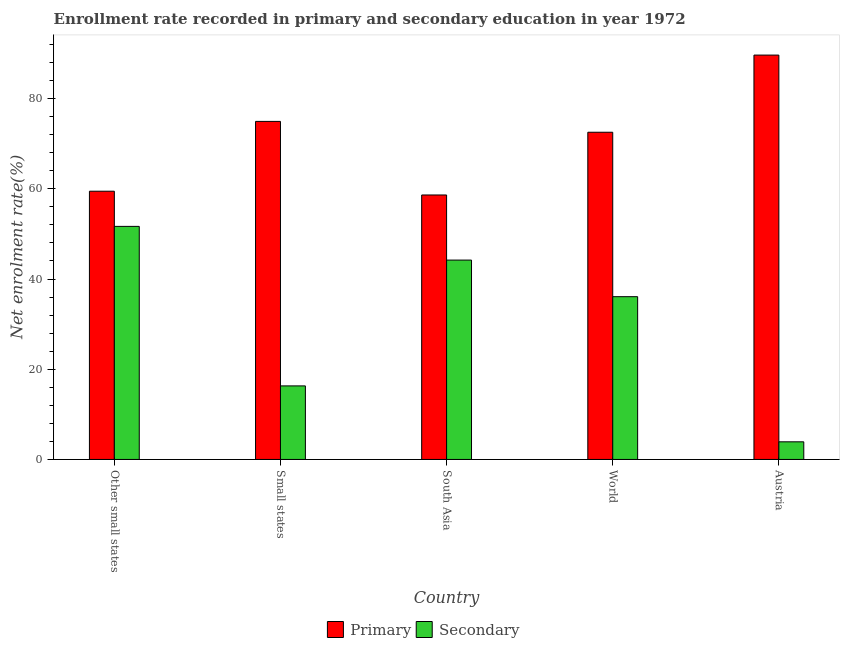How many different coloured bars are there?
Make the answer very short. 2. Are the number of bars on each tick of the X-axis equal?
Make the answer very short. Yes. How many bars are there on the 1st tick from the right?
Offer a terse response. 2. What is the label of the 1st group of bars from the left?
Keep it short and to the point. Other small states. What is the enrollment rate in secondary education in World?
Provide a short and direct response. 36.08. Across all countries, what is the maximum enrollment rate in primary education?
Keep it short and to the point. 89.64. Across all countries, what is the minimum enrollment rate in secondary education?
Give a very brief answer. 3.91. In which country was the enrollment rate in secondary education maximum?
Keep it short and to the point. Other small states. What is the total enrollment rate in secondary education in the graph?
Keep it short and to the point. 152.16. What is the difference between the enrollment rate in secondary education in Other small states and that in World?
Provide a succinct answer. 15.58. What is the difference between the enrollment rate in primary education in Small states and the enrollment rate in secondary education in South Asia?
Offer a terse response. 30.75. What is the average enrollment rate in primary education per country?
Keep it short and to the point. 71.04. What is the difference between the enrollment rate in secondary education and enrollment rate in primary education in Small states?
Your answer should be very brief. -58.63. In how many countries, is the enrollment rate in secondary education greater than 52 %?
Your answer should be compact. 0. What is the ratio of the enrollment rate in secondary education in Austria to that in South Asia?
Offer a very short reply. 0.09. What is the difference between the highest and the second highest enrollment rate in secondary education?
Offer a very short reply. 7.47. What is the difference between the highest and the lowest enrollment rate in primary education?
Give a very brief answer. 31.01. In how many countries, is the enrollment rate in primary education greater than the average enrollment rate in primary education taken over all countries?
Ensure brevity in your answer.  3. What does the 2nd bar from the left in South Asia represents?
Offer a terse response. Secondary. What does the 1st bar from the right in Other small states represents?
Provide a short and direct response. Secondary. How many bars are there?
Provide a short and direct response. 10. How many countries are there in the graph?
Offer a terse response. 5. What is the difference between two consecutive major ticks on the Y-axis?
Offer a very short reply. 20. Are the values on the major ticks of Y-axis written in scientific E-notation?
Your answer should be compact. No. Does the graph contain any zero values?
Ensure brevity in your answer.  No. Does the graph contain grids?
Your response must be concise. No. Where does the legend appear in the graph?
Your response must be concise. Bottom center. How are the legend labels stacked?
Your response must be concise. Horizontal. What is the title of the graph?
Offer a terse response. Enrollment rate recorded in primary and secondary education in year 1972. What is the label or title of the X-axis?
Your response must be concise. Country. What is the label or title of the Y-axis?
Offer a terse response. Net enrolment rate(%). What is the Net enrolment rate(%) in Primary in Other small states?
Offer a terse response. 59.47. What is the Net enrolment rate(%) of Secondary in Other small states?
Ensure brevity in your answer.  51.67. What is the Net enrolment rate(%) of Primary in Small states?
Provide a short and direct response. 74.94. What is the Net enrolment rate(%) of Secondary in Small states?
Your response must be concise. 16.31. What is the Net enrolment rate(%) of Primary in South Asia?
Make the answer very short. 58.63. What is the Net enrolment rate(%) of Secondary in South Asia?
Ensure brevity in your answer.  44.2. What is the Net enrolment rate(%) of Primary in World?
Make the answer very short. 72.54. What is the Net enrolment rate(%) of Secondary in World?
Offer a terse response. 36.08. What is the Net enrolment rate(%) of Primary in Austria?
Ensure brevity in your answer.  89.64. What is the Net enrolment rate(%) in Secondary in Austria?
Your answer should be compact. 3.91. Across all countries, what is the maximum Net enrolment rate(%) in Primary?
Offer a terse response. 89.64. Across all countries, what is the maximum Net enrolment rate(%) of Secondary?
Provide a succinct answer. 51.67. Across all countries, what is the minimum Net enrolment rate(%) in Primary?
Offer a terse response. 58.63. Across all countries, what is the minimum Net enrolment rate(%) of Secondary?
Keep it short and to the point. 3.91. What is the total Net enrolment rate(%) of Primary in the graph?
Make the answer very short. 355.21. What is the total Net enrolment rate(%) of Secondary in the graph?
Your response must be concise. 152.16. What is the difference between the Net enrolment rate(%) in Primary in Other small states and that in Small states?
Your response must be concise. -15.47. What is the difference between the Net enrolment rate(%) in Secondary in Other small states and that in Small states?
Your response must be concise. 35.36. What is the difference between the Net enrolment rate(%) in Primary in Other small states and that in South Asia?
Ensure brevity in your answer.  0.83. What is the difference between the Net enrolment rate(%) in Secondary in Other small states and that in South Asia?
Make the answer very short. 7.47. What is the difference between the Net enrolment rate(%) in Primary in Other small states and that in World?
Offer a terse response. -13.07. What is the difference between the Net enrolment rate(%) of Secondary in Other small states and that in World?
Offer a very short reply. 15.58. What is the difference between the Net enrolment rate(%) in Primary in Other small states and that in Austria?
Provide a short and direct response. -30.17. What is the difference between the Net enrolment rate(%) in Secondary in Other small states and that in Austria?
Make the answer very short. 47.76. What is the difference between the Net enrolment rate(%) of Primary in Small states and that in South Asia?
Make the answer very short. 16.31. What is the difference between the Net enrolment rate(%) of Secondary in Small states and that in South Asia?
Your answer should be very brief. -27.89. What is the difference between the Net enrolment rate(%) of Primary in Small states and that in World?
Provide a succinct answer. 2.4. What is the difference between the Net enrolment rate(%) in Secondary in Small states and that in World?
Give a very brief answer. -19.78. What is the difference between the Net enrolment rate(%) of Primary in Small states and that in Austria?
Keep it short and to the point. -14.7. What is the difference between the Net enrolment rate(%) in Secondary in Small states and that in Austria?
Offer a very short reply. 12.4. What is the difference between the Net enrolment rate(%) of Primary in South Asia and that in World?
Your answer should be very brief. -13.91. What is the difference between the Net enrolment rate(%) in Secondary in South Asia and that in World?
Provide a short and direct response. 8.11. What is the difference between the Net enrolment rate(%) of Primary in South Asia and that in Austria?
Keep it short and to the point. -31.01. What is the difference between the Net enrolment rate(%) of Secondary in South Asia and that in Austria?
Your answer should be very brief. 40.29. What is the difference between the Net enrolment rate(%) of Primary in World and that in Austria?
Give a very brief answer. -17.1. What is the difference between the Net enrolment rate(%) in Secondary in World and that in Austria?
Offer a terse response. 32.18. What is the difference between the Net enrolment rate(%) in Primary in Other small states and the Net enrolment rate(%) in Secondary in Small states?
Give a very brief answer. 43.16. What is the difference between the Net enrolment rate(%) of Primary in Other small states and the Net enrolment rate(%) of Secondary in South Asia?
Give a very brief answer. 15.27. What is the difference between the Net enrolment rate(%) in Primary in Other small states and the Net enrolment rate(%) in Secondary in World?
Make the answer very short. 23.38. What is the difference between the Net enrolment rate(%) of Primary in Other small states and the Net enrolment rate(%) of Secondary in Austria?
Make the answer very short. 55.56. What is the difference between the Net enrolment rate(%) of Primary in Small states and the Net enrolment rate(%) of Secondary in South Asia?
Keep it short and to the point. 30.75. What is the difference between the Net enrolment rate(%) in Primary in Small states and the Net enrolment rate(%) in Secondary in World?
Make the answer very short. 38.86. What is the difference between the Net enrolment rate(%) of Primary in Small states and the Net enrolment rate(%) of Secondary in Austria?
Provide a succinct answer. 71.03. What is the difference between the Net enrolment rate(%) in Primary in South Asia and the Net enrolment rate(%) in Secondary in World?
Keep it short and to the point. 22.55. What is the difference between the Net enrolment rate(%) in Primary in South Asia and the Net enrolment rate(%) in Secondary in Austria?
Give a very brief answer. 54.72. What is the difference between the Net enrolment rate(%) of Primary in World and the Net enrolment rate(%) of Secondary in Austria?
Keep it short and to the point. 68.63. What is the average Net enrolment rate(%) in Primary per country?
Give a very brief answer. 71.04. What is the average Net enrolment rate(%) of Secondary per country?
Provide a short and direct response. 30.43. What is the difference between the Net enrolment rate(%) in Primary and Net enrolment rate(%) in Secondary in Other small states?
Your answer should be compact. 7.8. What is the difference between the Net enrolment rate(%) of Primary and Net enrolment rate(%) of Secondary in Small states?
Provide a short and direct response. 58.63. What is the difference between the Net enrolment rate(%) in Primary and Net enrolment rate(%) in Secondary in South Asia?
Ensure brevity in your answer.  14.44. What is the difference between the Net enrolment rate(%) in Primary and Net enrolment rate(%) in Secondary in World?
Give a very brief answer. 36.45. What is the difference between the Net enrolment rate(%) in Primary and Net enrolment rate(%) in Secondary in Austria?
Give a very brief answer. 85.73. What is the ratio of the Net enrolment rate(%) in Primary in Other small states to that in Small states?
Ensure brevity in your answer.  0.79. What is the ratio of the Net enrolment rate(%) in Secondary in Other small states to that in Small states?
Keep it short and to the point. 3.17. What is the ratio of the Net enrolment rate(%) in Primary in Other small states to that in South Asia?
Offer a terse response. 1.01. What is the ratio of the Net enrolment rate(%) of Secondary in Other small states to that in South Asia?
Your response must be concise. 1.17. What is the ratio of the Net enrolment rate(%) in Primary in Other small states to that in World?
Ensure brevity in your answer.  0.82. What is the ratio of the Net enrolment rate(%) of Secondary in Other small states to that in World?
Give a very brief answer. 1.43. What is the ratio of the Net enrolment rate(%) in Primary in Other small states to that in Austria?
Keep it short and to the point. 0.66. What is the ratio of the Net enrolment rate(%) of Secondary in Other small states to that in Austria?
Your answer should be compact. 13.22. What is the ratio of the Net enrolment rate(%) of Primary in Small states to that in South Asia?
Provide a short and direct response. 1.28. What is the ratio of the Net enrolment rate(%) of Secondary in Small states to that in South Asia?
Make the answer very short. 0.37. What is the ratio of the Net enrolment rate(%) of Primary in Small states to that in World?
Your answer should be compact. 1.03. What is the ratio of the Net enrolment rate(%) of Secondary in Small states to that in World?
Offer a very short reply. 0.45. What is the ratio of the Net enrolment rate(%) in Primary in Small states to that in Austria?
Offer a very short reply. 0.84. What is the ratio of the Net enrolment rate(%) of Secondary in Small states to that in Austria?
Provide a succinct answer. 4.17. What is the ratio of the Net enrolment rate(%) in Primary in South Asia to that in World?
Keep it short and to the point. 0.81. What is the ratio of the Net enrolment rate(%) of Secondary in South Asia to that in World?
Ensure brevity in your answer.  1.22. What is the ratio of the Net enrolment rate(%) of Primary in South Asia to that in Austria?
Offer a terse response. 0.65. What is the ratio of the Net enrolment rate(%) of Secondary in South Asia to that in Austria?
Offer a terse response. 11.31. What is the ratio of the Net enrolment rate(%) of Primary in World to that in Austria?
Keep it short and to the point. 0.81. What is the ratio of the Net enrolment rate(%) of Secondary in World to that in Austria?
Keep it short and to the point. 9.23. What is the difference between the highest and the second highest Net enrolment rate(%) of Primary?
Ensure brevity in your answer.  14.7. What is the difference between the highest and the second highest Net enrolment rate(%) of Secondary?
Your answer should be compact. 7.47. What is the difference between the highest and the lowest Net enrolment rate(%) of Primary?
Provide a short and direct response. 31.01. What is the difference between the highest and the lowest Net enrolment rate(%) in Secondary?
Your answer should be very brief. 47.76. 